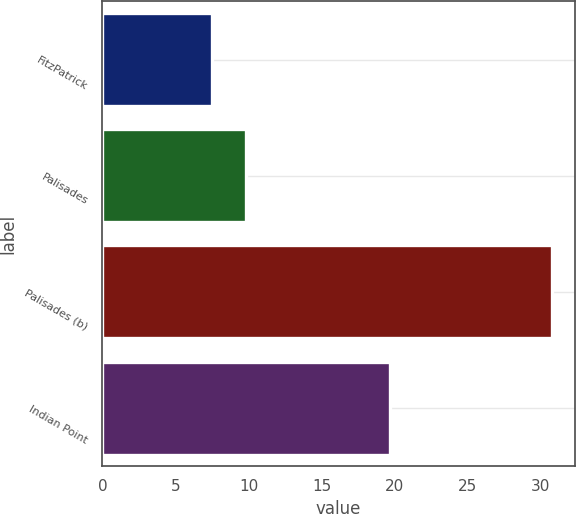Convert chart. <chart><loc_0><loc_0><loc_500><loc_500><bar_chart><fcel>FitzPatrick<fcel>Palisades<fcel>Palisades (b)<fcel>Indian Point<nl><fcel>7.5<fcel>9.83<fcel>30.8<fcel>19.7<nl></chart> 